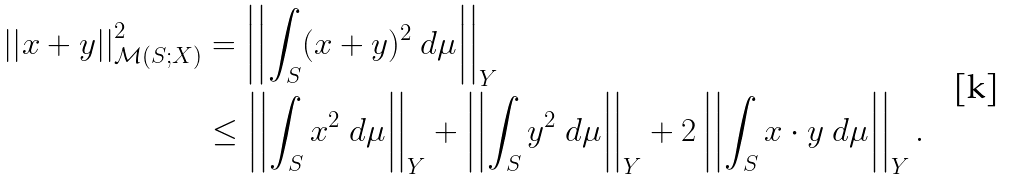<formula> <loc_0><loc_0><loc_500><loc_500>\left | \left | x + y \right | \right | ^ { 2 } _ { \mathcal { M } ( S ; X ) } & = \left | \left | \int _ { S } ( x + y ) ^ { 2 } \ d \mu \right | \right | _ { Y } \\ & \leq \left | \left | \int _ { S } x ^ { 2 } \ d \mu \right | \right | _ { Y } + \left | \left | \int _ { S } y ^ { 2 } \ d \mu \right | \right | _ { Y } + 2 \left | \left | \int _ { S } x \cdot y \ d \mu \right | \right | _ { Y } .</formula> 